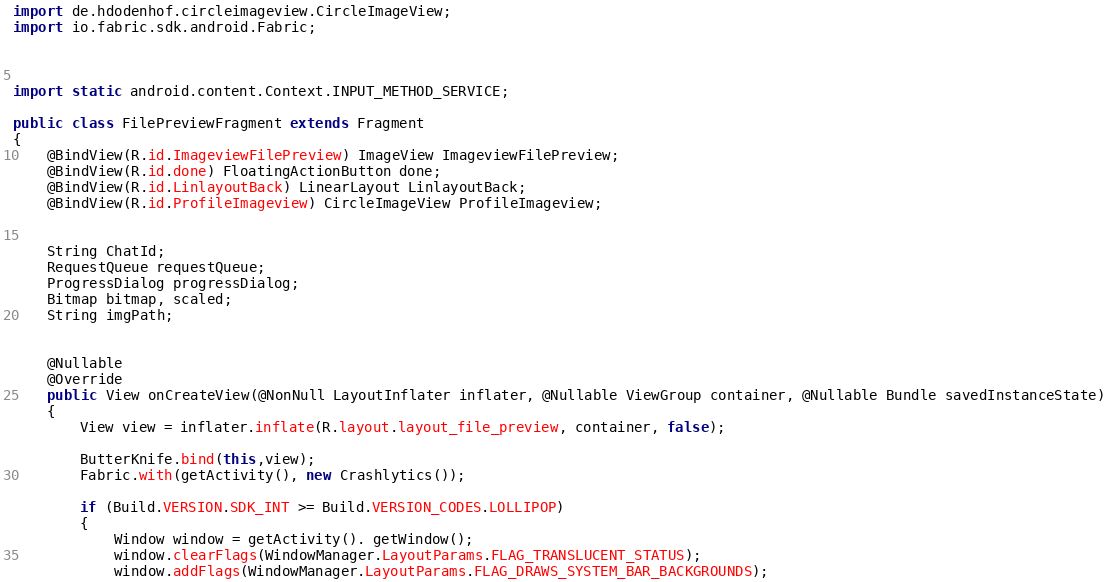Convert code to text. <code><loc_0><loc_0><loc_500><loc_500><_Java_>import de.hdodenhof.circleimageview.CircleImageView;
import io.fabric.sdk.android.Fabric;



import static android.content.Context.INPUT_METHOD_SERVICE;

public class FilePreviewFragment extends Fragment
{
    @BindView(R.id.ImageviewFilePreview) ImageView ImageviewFilePreview;
    @BindView(R.id.done) FloatingActionButton done;
    @BindView(R.id.LinlayoutBack) LinearLayout LinlayoutBack;
    @BindView(R.id.ProfileImageview) CircleImageView ProfileImageview;


    String ChatId;
    RequestQueue requestQueue;
    ProgressDialog progressDialog;
    Bitmap bitmap, scaled;
    String imgPath;


    @Nullable
    @Override
    public View onCreateView(@NonNull LayoutInflater inflater, @Nullable ViewGroup container, @Nullable Bundle savedInstanceState)
    {
        View view = inflater.inflate(R.layout.layout_file_preview, container, false);

        ButterKnife.bind(this,view);
        Fabric.with(getActivity(), new Crashlytics());

        if (Build.VERSION.SDK_INT >= Build.VERSION_CODES.LOLLIPOP)
        {
            Window window = getActivity(). getWindow();
            window.clearFlags(WindowManager.LayoutParams.FLAG_TRANSLUCENT_STATUS);
            window.addFlags(WindowManager.LayoutParams.FLAG_DRAWS_SYSTEM_BAR_BACKGROUNDS);</code> 